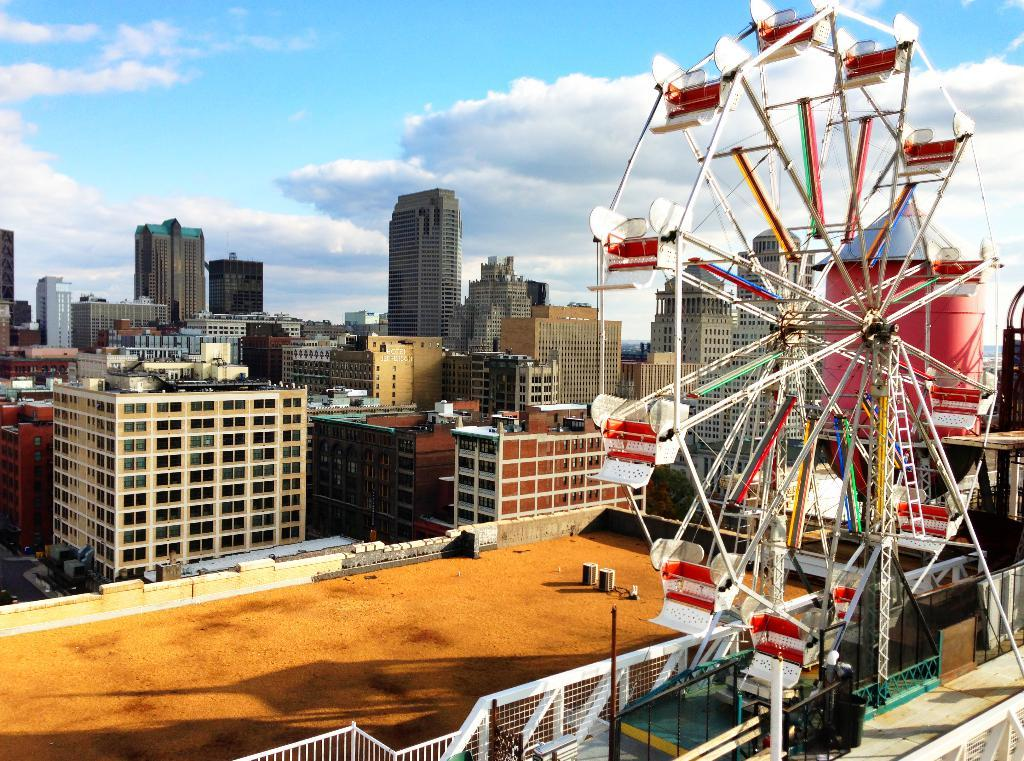What type of structures are visible in the image? There is a group of buildings in the image. What can be seen in the sky in the image? The sky is visible at the top of the image. What amusement park ride is present on the right side of the image? There is a giant wheel on the right side of the image. What type of barrier is present at the bottom of the image? A metal fence is present at the bottom of the image. What type of haircut is the building on the left side of the image getting? There is no haircut or building getting a haircut present in the image. How does the behavior of the metal fence change throughout the day in the image? The behavior of the metal fence does not change throughout the day in the image; it remains stationary. 